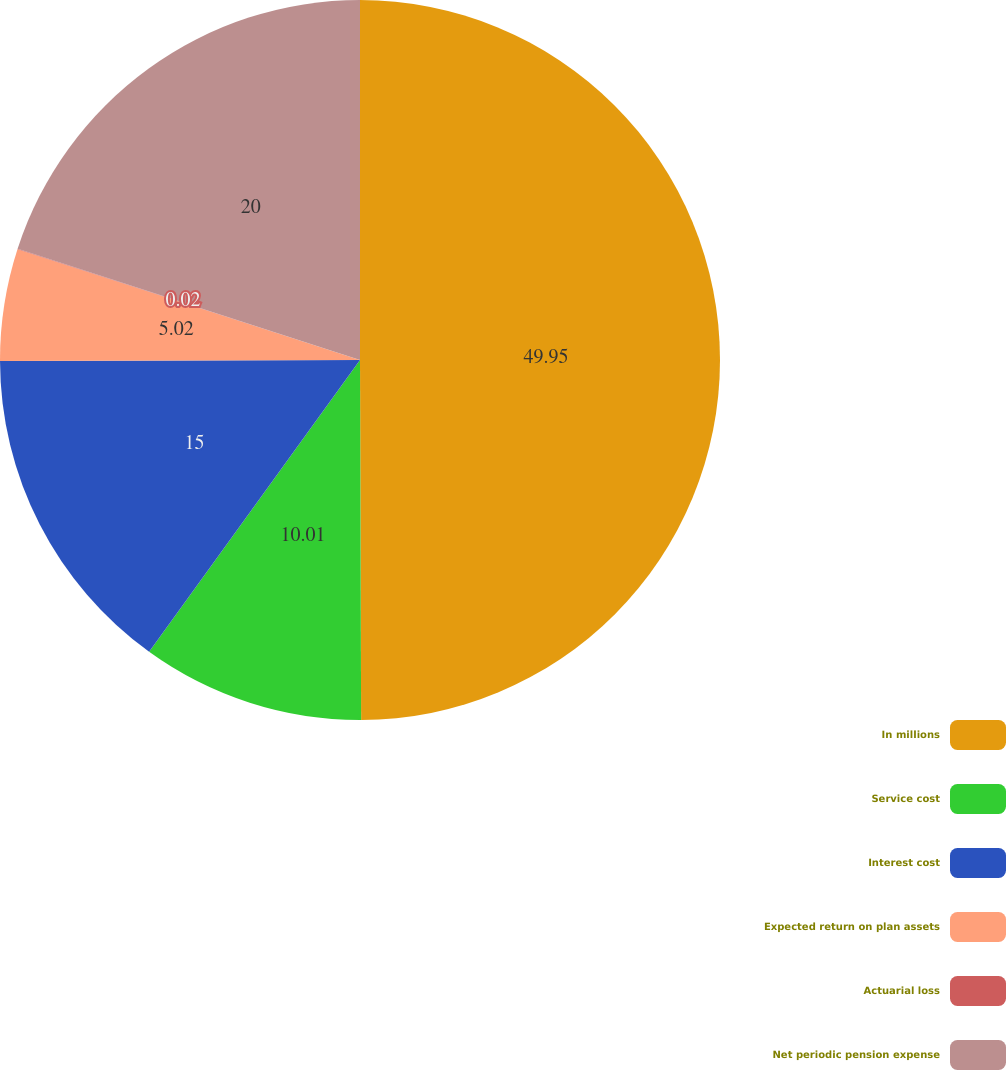<chart> <loc_0><loc_0><loc_500><loc_500><pie_chart><fcel>In millions<fcel>Service cost<fcel>Interest cost<fcel>Expected return on plan assets<fcel>Actuarial loss<fcel>Net periodic pension expense<nl><fcel>49.95%<fcel>10.01%<fcel>15.0%<fcel>5.02%<fcel>0.02%<fcel>20.0%<nl></chart> 